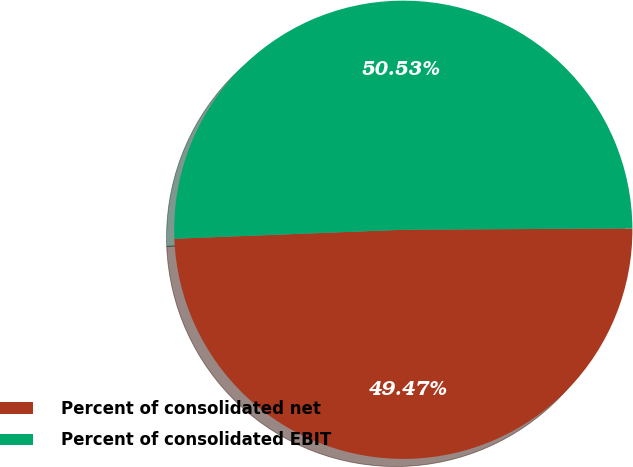Convert chart to OTSL. <chart><loc_0><loc_0><loc_500><loc_500><pie_chart><fcel>Percent of consolidated net<fcel>Percent of consolidated EBIT<nl><fcel>49.47%<fcel>50.53%<nl></chart> 